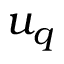<formula> <loc_0><loc_0><loc_500><loc_500>u _ { q }</formula> 